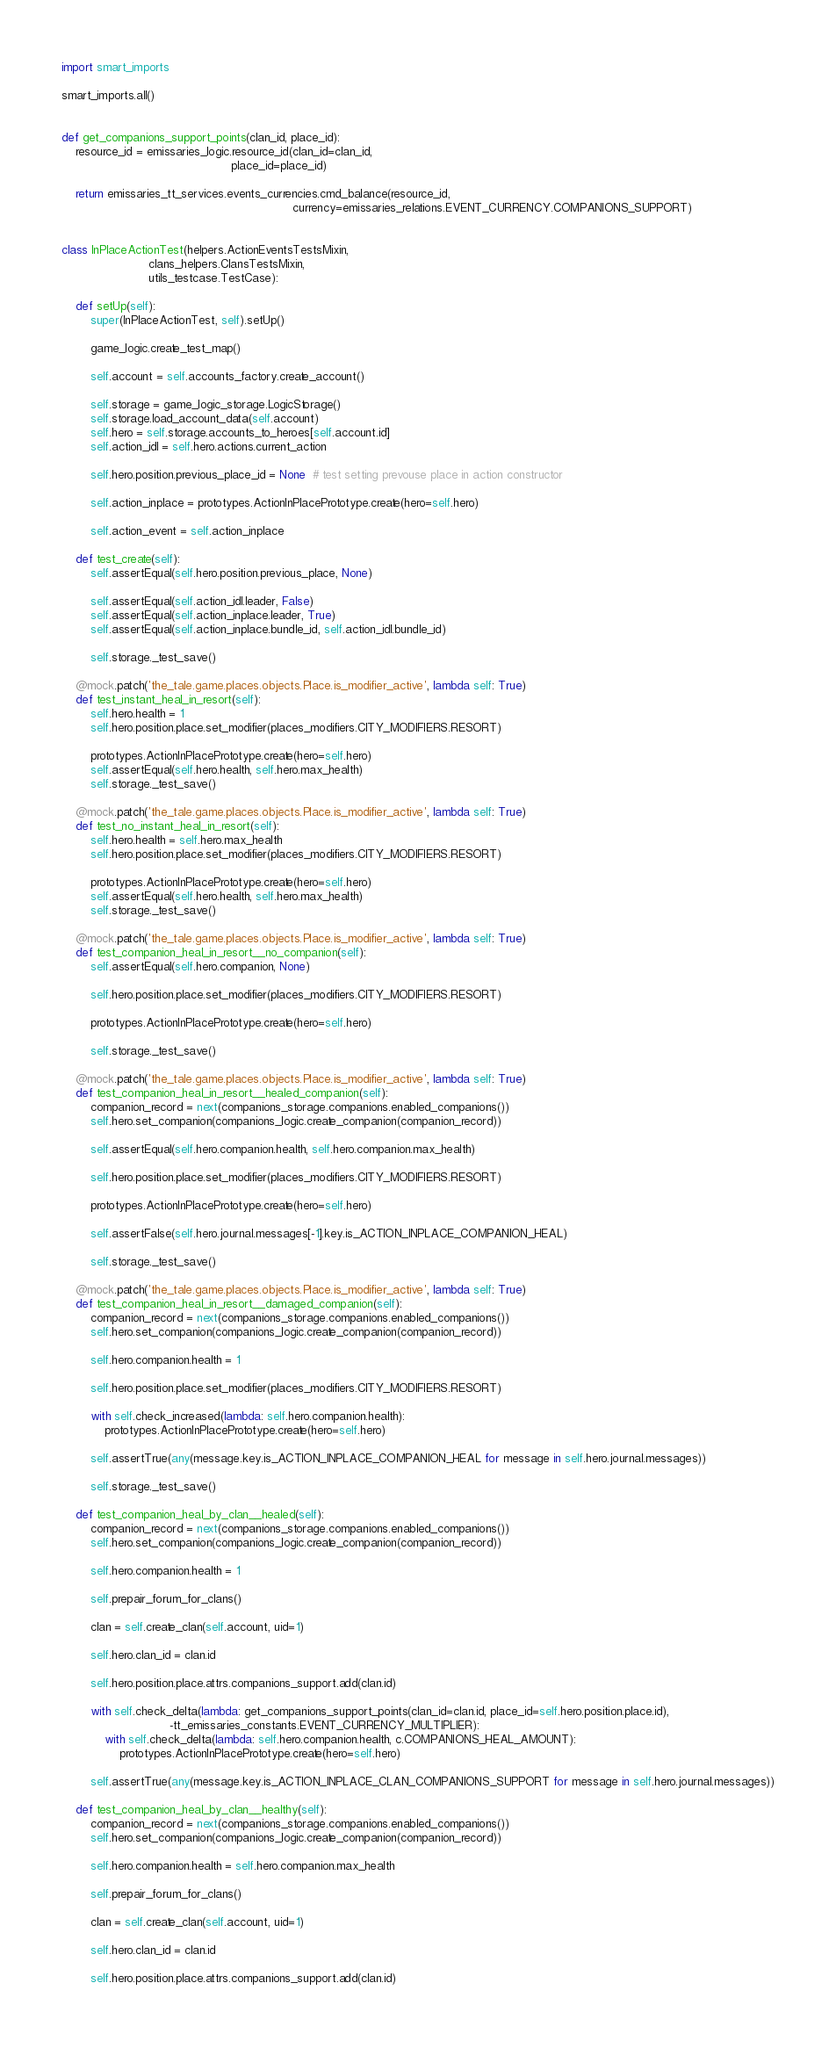Convert code to text. <code><loc_0><loc_0><loc_500><loc_500><_Python_>
import smart_imports

smart_imports.all()


def get_companions_support_points(clan_id, place_id):
    resource_id = emissaries_logic.resource_id(clan_id=clan_id,
                                               place_id=place_id)

    return emissaries_tt_services.events_currencies.cmd_balance(resource_id,
                                                                currency=emissaries_relations.EVENT_CURRENCY.COMPANIONS_SUPPORT)


class InPlaceActionTest(helpers.ActionEventsTestsMixin,
                        clans_helpers.ClansTestsMixin,
                        utils_testcase.TestCase):

    def setUp(self):
        super(InPlaceActionTest, self).setUp()

        game_logic.create_test_map()

        self.account = self.accounts_factory.create_account()

        self.storage = game_logic_storage.LogicStorage()
        self.storage.load_account_data(self.account)
        self.hero = self.storage.accounts_to_heroes[self.account.id]
        self.action_idl = self.hero.actions.current_action

        self.hero.position.previous_place_id = None  # test setting prevouse place in action constructor

        self.action_inplace = prototypes.ActionInPlacePrototype.create(hero=self.hero)

        self.action_event = self.action_inplace

    def test_create(self):
        self.assertEqual(self.hero.position.previous_place, None)

        self.assertEqual(self.action_idl.leader, False)
        self.assertEqual(self.action_inplace.leader, True)
        self.assertEqual(self.action_inplace.bundle_id, self.action_idl.bundle_id)

        self.storage._test_save()

    @mock.patch('the_tale.game.places.objects.Place.is_modifier_active', lambda self: True)
    def test_instant_heal_in_resort(self):
        self.hero.health = 1
        self.hero.position.place.set_modifier(places_modifiers.CITY_MODIFIERS.RESORT)

        prototypes.ActionInPlacePrototype.create(hero=self.hero)
        self.assertEqual(self.hero.health, self.hero.max_health)
        self.storage._test_save()

    @mock.patch('the_tale.game.places.objects.Place.is_modifier_active', lambda self: True)
    def test_no_instant_heal_in_resort(self):
        self.hero.health = self.hero.max_health
        self.hero.position.place.set_modifier(places_modifiers.CITY_MODIFIERS.RESORT)

        prototypes.ActionInPlacePrototype.create(hero=self.hero)
        self.assertEqual(self.hero.health, self.hero.max_health)
        self.storage._test_save()

    @mock.patch('the_tale.game.places.objects.Place.is_modifier_active', lambda self: True)
    def test_companion_heal_in_resort__no_companion(self):
        self.assertEqual(self.hero.companion, None)

        self.hero.position.place.set_modifier(places_modifiers.CITY_MODIFIERS.RESORT)

        prototypes.ActionInPlacePrototype.create(hero=self.hero)

        self.storage._test_save()

    @mock.patch('the_tale.game.places.objects.Place.is_modifier_active', lambda self: True)
    def test_companion_heal_in_resort__healed_companion(self):
        companion_record = next(companions_storage.companions.enabled_companions())
        self.hero.set_companion(companions_logic.create_companion(companion_record))

        self.assertEqual(self.hero.companion.health, self.hero.companion.max_health)

        self.hero.position.place.set_modifier(places_modifiers.CITY_MODIFIERS.RESORT)

        prototypes.ActionInPlacePrototype.create(hero=self.hero)

        self.assertFalse(self.hero.journal.messages[-1].key.is_ACTION_INPLACE_COMPANION_HEAL)

        self.storage._test_save()

    @mock.patch('the_tale.game.places.objects.Place.is_modifier_active', lambda self: True)
    def test_companion_heal_in_resort__damaged_companion(self):
        companion_record = next(companions_storage.companions.enabled_companions())
        self.hero.set_companion(companions_logic.create_companion(companion_record))

        self.hero.companion.health = 1

        self.hero.position.place.set_modifier(places_modifiers.CITY_MODIFIERS.RESORT)

        with self.check_increased(lambda: self.hero.companion.health):
            prototypes.ActionInPlacePrototype.create(hero=self.hero)

        self.assertTrue(any(message.key.is_ACTION_INPLACE_COMPANION_HEAL for message in self.hero.journal.messages))

        self.storage._test_save()

    def test_companion_heal_by_clan__healed(self):
        companion_record = next(companions_storage.companions.enabled_companions())
        self.hero.set_companion(companions_logic.create_companion(companion_record))

        self.hero.companion.health = 1

        self.prepair_forum_for_clans()

        clan = self.create_clan(self.account, uid=1)

        self.hero.clan_id = clan.id

        self.hero.position.place.attrs.companions_support.add(clan.id)

        with self.check_delta(lambda: get_companions_support_points(clan_id=clan.id, place_id=self.hero.position.place.id),
                              -tt_emissaries_constants.EVENT_CURRENCY_MULTIPLIER):
            with self.check_delta(lambda: self.hero.companion.health, c.COMPANIONS_HEAL_AMOUNT):
                prototypes.ActionInPlacePrototype.create(hero=self.hero)

        self.assertTrue(any(message.key.is_ACTION_INPLACE_CLAN_COMPANIONS_SUPPORT for message in self.hero.journal.messages))

    def test_companion_heal_by_clan__healthy(self):
        companion_record = next(companions_storage.companions.enabled_companions())
        self.hero.set_companion(companions_logic.create_companion(companion_record))

        self.hero.companion.health = self.hero.companion.max_health

        self.prepair_forum_for_clans()

        clan = self.create_clan(self.account, uid=1)

        self.hero.clan_id = clan.id

        self.hero.position.place.attrs.companions_support.add(clan.id)
</code> 